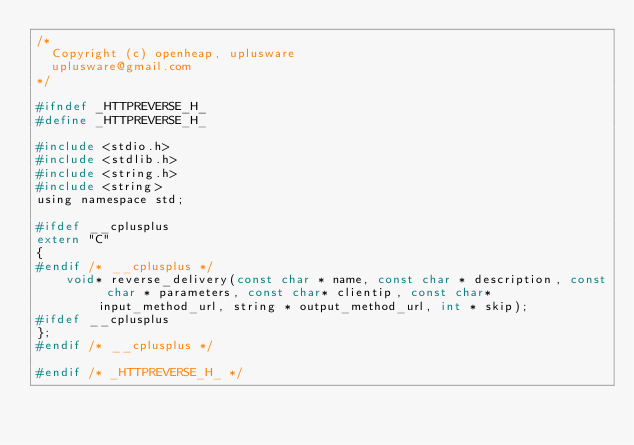Convert code to text. <code><loc_0><loc_0><loc_500><loc_500><_C_>/*
	Copyright (c) openheap, uplusware
	uplusware@gmail.com
*/

#ifndef _HTTPREVERSE_H_
#define _HTTPREVERSE_H_

#include <stdio.h>
#include <stdlib.h>
#include <string.h>
#include <string>
using namespace std;

#ifdef __cplusplus
extern "C"
{
#endif /* __cplusplus */
    void* reverse_delivery(const char * name, const char * description, const char * parameters, const char* clientip, const char* input_method_url, string * output_method_url, int * skip);
#ifdef __cplusplus
};
#endif /* __cplusplus */

#endif /* _HTTPREVERSE_H_ */
</code> 